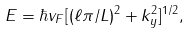Convert formula to latex. <formula><loc_0><loc_0><loc_500><loc_500>E = \hbar { v } _ { F } [ ( \ell \pi / L ) ^ { 2 } + k _ { y } ^ { 2 } ] ^ { 1 / 2 } ,</formula> 